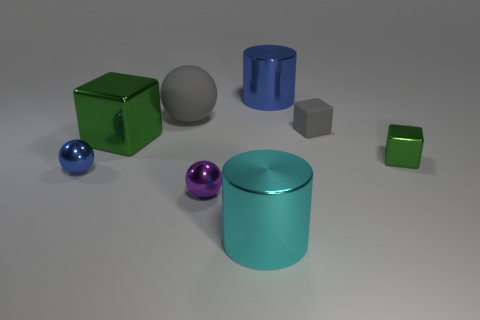Do the matte ball and the small thing behind the tiny green shiny thing have the same color?
Your answer should be compact. Yes. Are there any blue metal things that have the same shape as the small purple metallic object?
Your answer should be very brief. Yes. What is the material of the object that is the same color as the matte cube?
Your response must be concise. Rubber. The small thing behind the big shiny thing that is on the left side of the small purple sphere is what shape?
Your answer should be very brief. Cube. How many large cyan cylinders have the same material as the tiny blue object?
Make the answer very short. 1. There is a tiny cube that is the same material as the large green block; what is its color?
Offer a terse response. Green. There is a cylinder behind the small block behind the green thing that is on the right side of the purple metallic sphere; what size is it?
Provide a succinct answer. Large. Is the number of small blue balls less than the number of blue shiny objects?
Your response must be concise. Yes. There is another thing that is the same shape as the large cyan thing; what is its color?
Offer a terse response. Blue. There is a cylinder that is behind the blue shiny thing that is left of the cyan cylinder; is there a cyan thing in front of it?
Offer a terse response. Yes. 